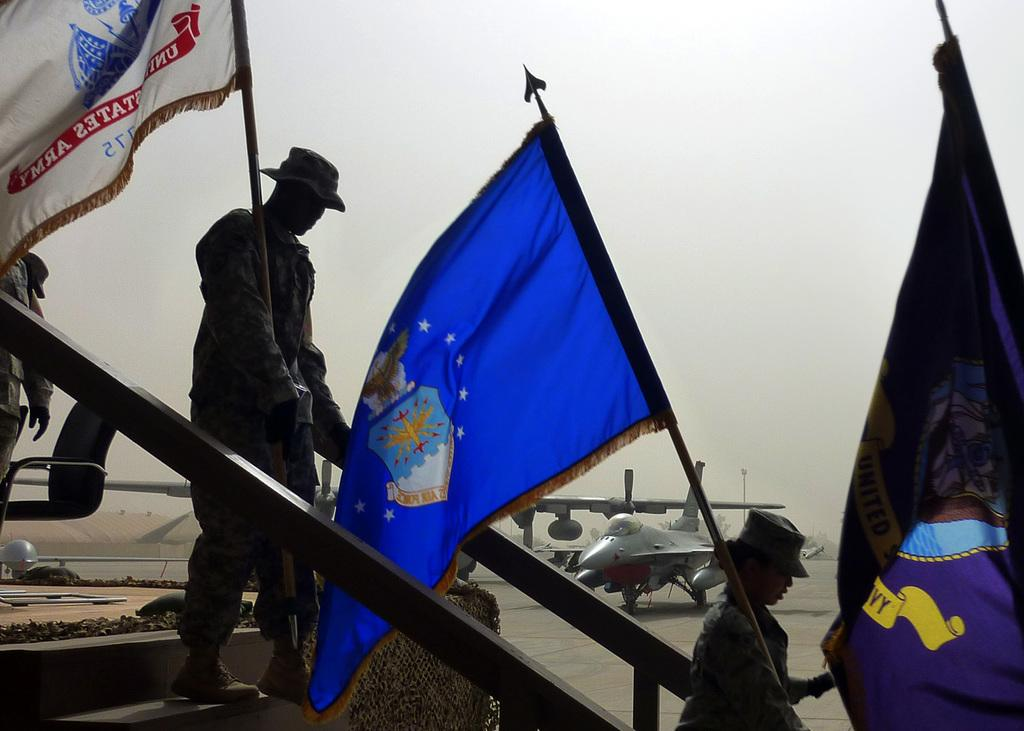What are the people in the image doing? The people in the image are walking on the stairs. What are the people holding while walking on the stairs? The people are holding flags. What else can be seen in the image besides the people on the stairs? There are airplanes visible in the image. What is on the ground in the image? There are objects on the ground. What can be seen in the background of the image? The sky is visible in the background of the image. What type of toothbrush is being used by the people walking on the stairs? There is no toothbrush present in the image; the people are holding flags. What color is the powder on the ground in the image? There is no powder present on the ground in the image; there are only objects visible. 